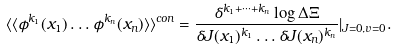Convert formula to latex. <formula><loc_0><loc_0><loc_500><loc_500>\langle \langle \phi ^ { k _ { 1 } } ( { x } _ { 1 } ) \dots \phi ^ { k _ { n } } ( { x } _ { n } ) \rangle \rangle ^ { c o n } = \frac { \delta ^ { k _ { 1 } + \dots + k _ { n } } \log \Delta \Xi } { \delta J ( { x } _ { 1 } ) ^ { k _ { 1 } } \dots \delta J ( { x } _ { n } ) ^ { k _ { n } } } | _ { J = 0 , v = 0 } .</formula> 